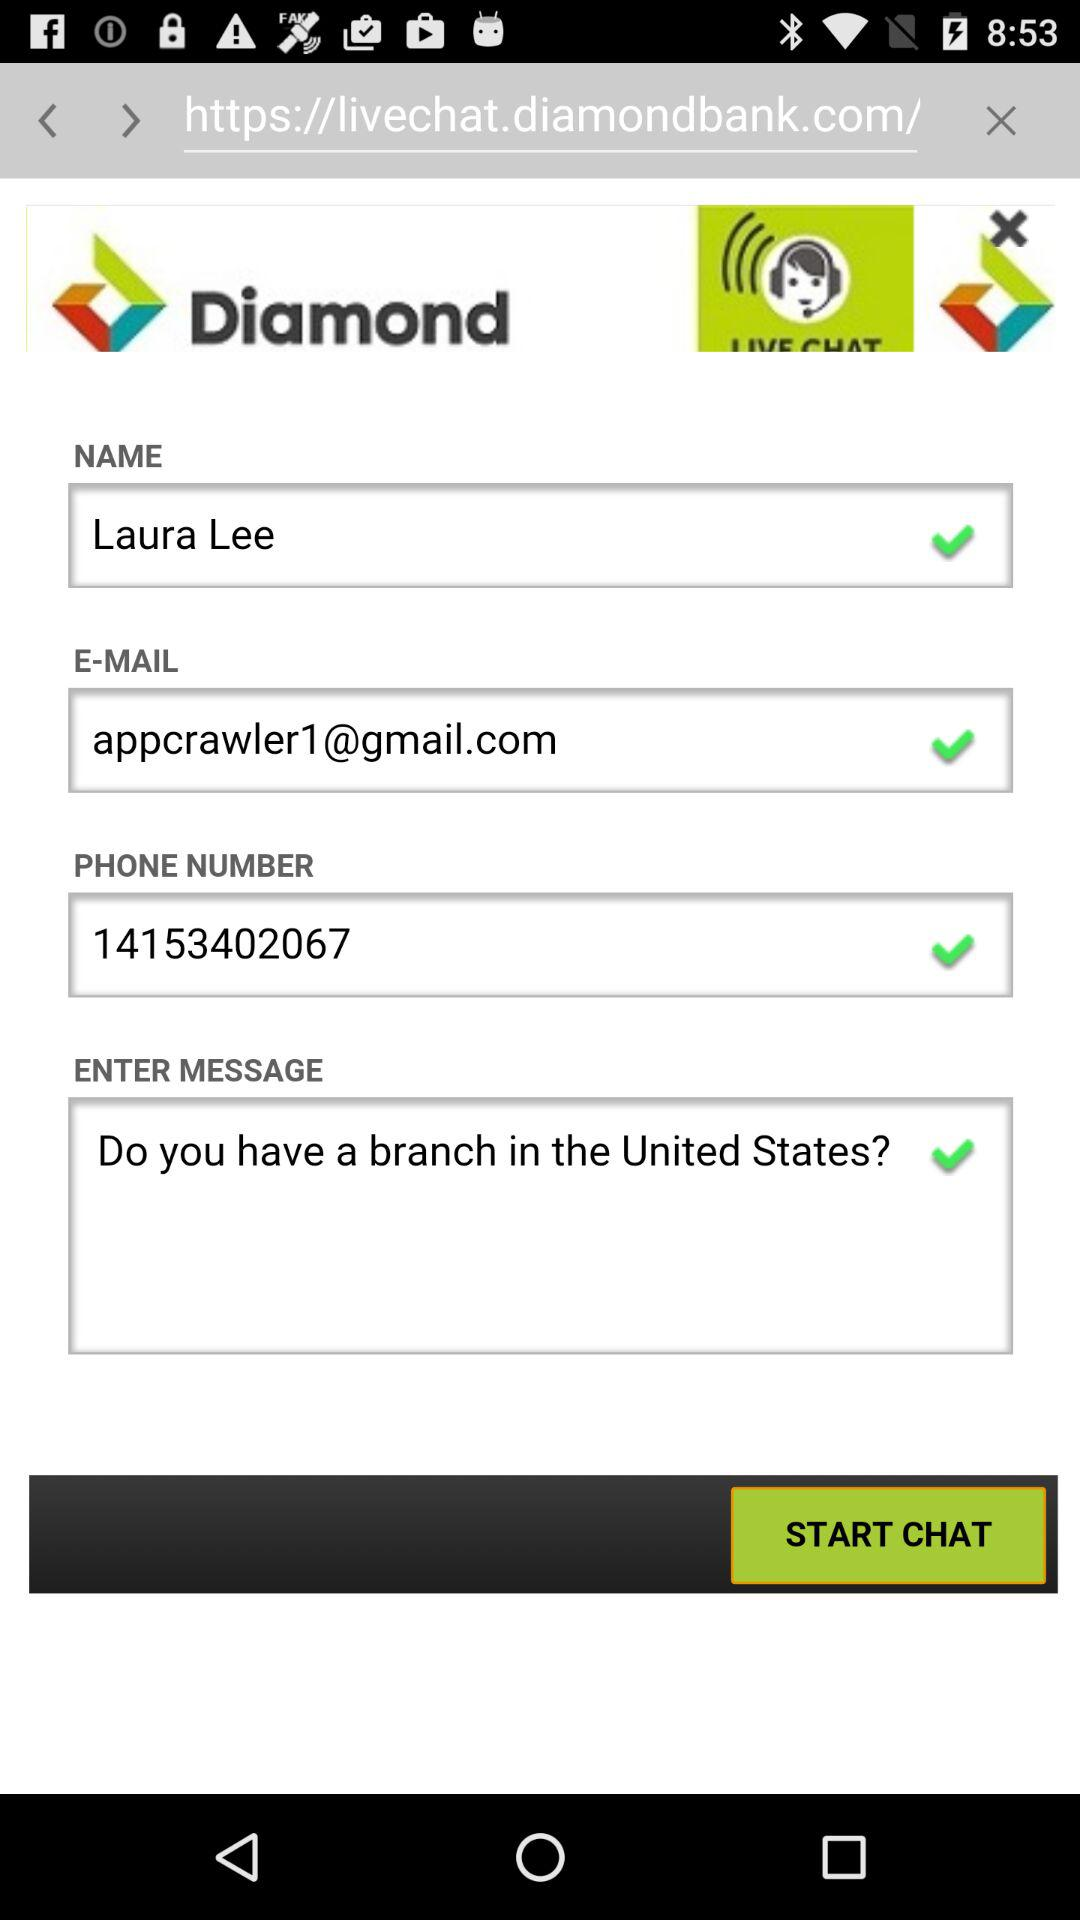What is the name? The name is Laura Lee. 